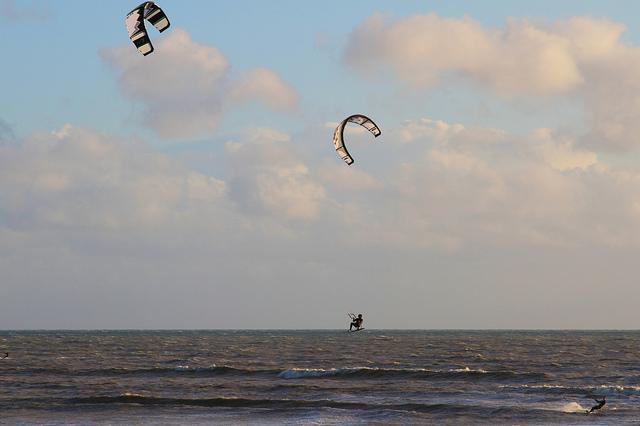How many kites are flying?
Give a very brief answer. 2. How many people are in this photo?
Give a very brief answer. 2. How many kites can be seen?
Give a very brief answer. 2. 